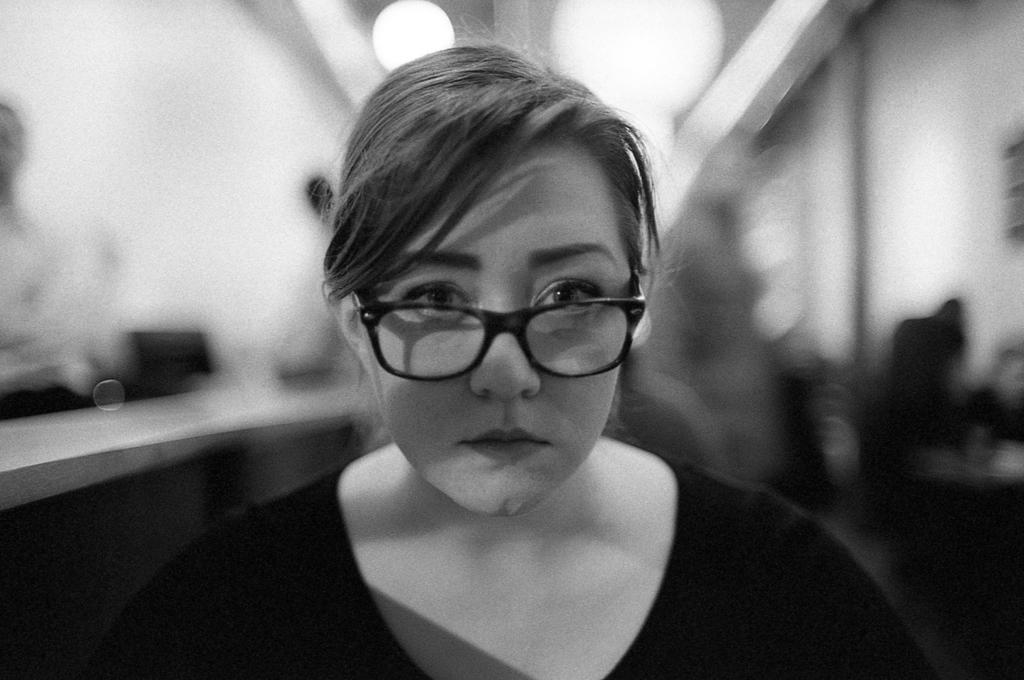Describe this image in one or two sentences. In this image I can see a woman is looking at this side, she wore t-shirt, black color spectacles. 